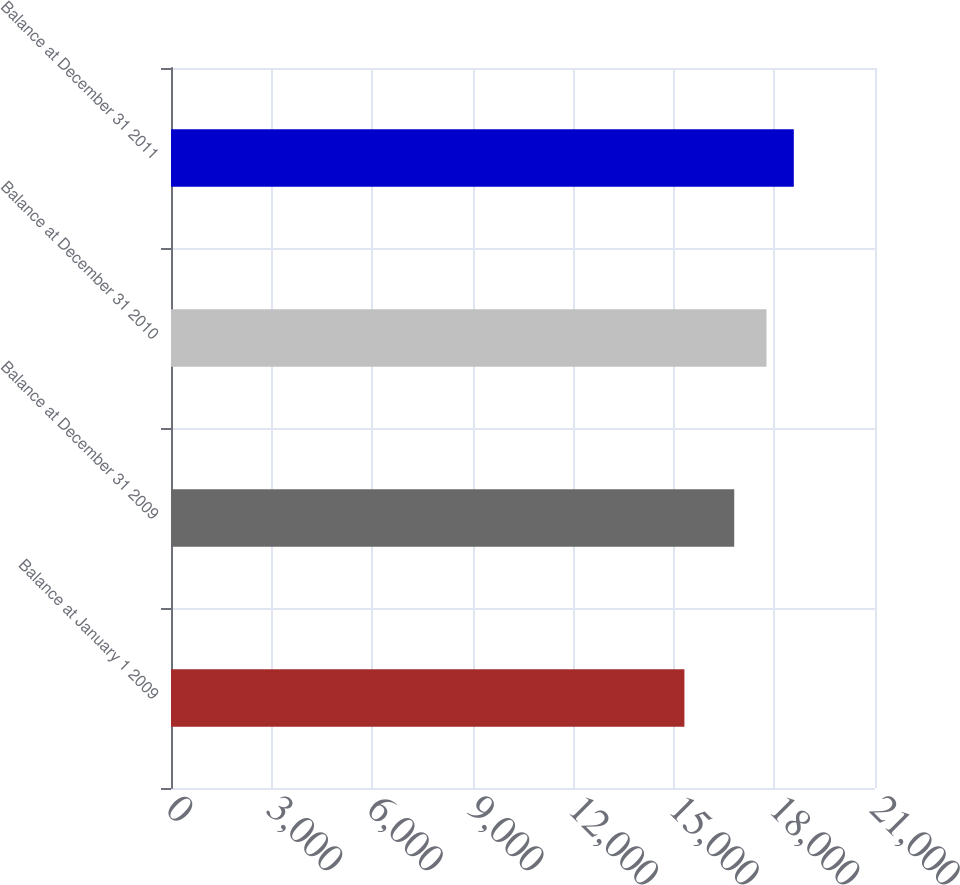Convert chart. <chart><loc_0><loc_0><loc_500><loc_500><bar_chart><fcel>Balance at January 1 2009<fcel>Balance at December 31 2009<fcel>Balance at December 31 2010<fcel>Balance at December 31 2011<nl><fcel>15315<fcel>16801<fcel>17763<fcel>18578<nl></chart> 